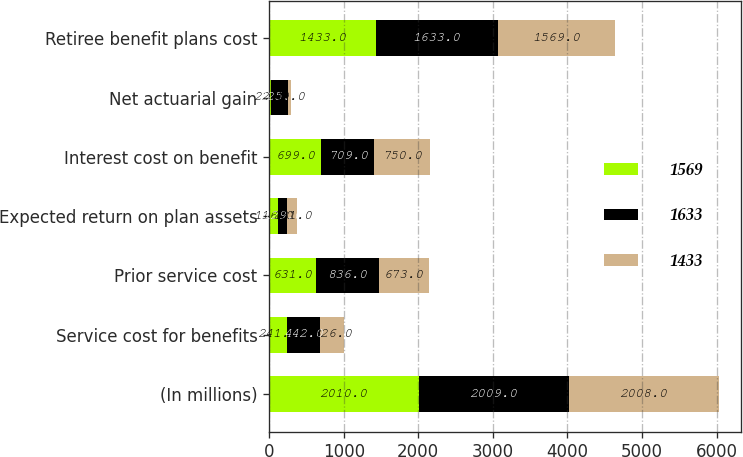Convert chart. <chart><loc_0><loc_0><loc_500><loc_500><stacked_bar_chart><ecel><fcel>(In millions)<fcel>Service cost for benefits<fcel>Prior service cost<fcel>Expected return on plan assets<fcel>Interest cost on benefit<fcel>Net actuarial gain<fcel>Retiree benefit plans cost<nl><fcel>1569<fcel>2010<fcel>241<fcel>631<fcel>116<fcel>699<fcel>22<fcel>1433<nl><fcel>1633<fcel>2009<fcel>442<fcel>836<fcel>129<fcel>709<fcel>225<fcel>1633<nl><fcel>1433<fcel>2008<fcel>326<fcel>673<fcel>131<fcel>750<fcel>49<fcel>1569<nl></chart> 